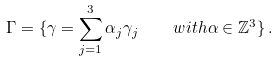<formula> <loc_0><loc_0><loc_500><loc_500>\Gamma = \{ \gamma = \sum ^ { 3 } _ { j = 1 } \alpha _ { j } \gamma _ { j } \quad w i t h \alpha \in \mathbb { Z } ^ { 3 } \} \, .</formula> 